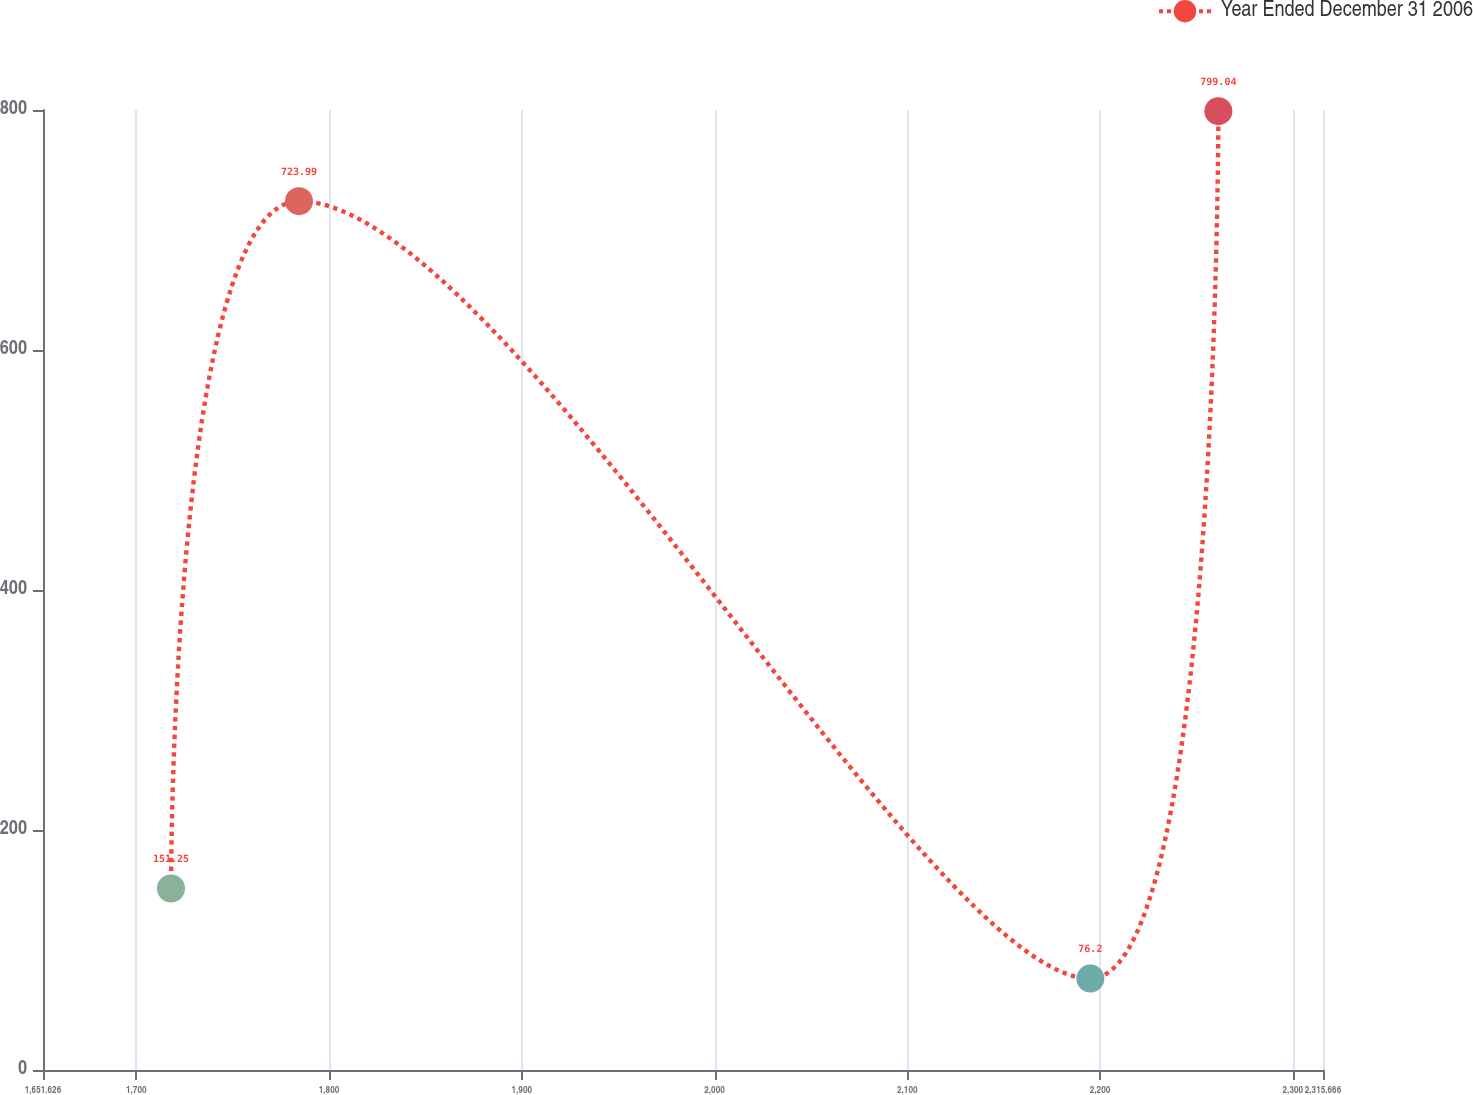<chart> <loc_0><loc_0><loc_500><loc_500><line_chart><ecel><fcel>Year Ended December 31 2006<nl><fcel>1718.03<fcel>151.25<nl><fcel>1784.43<fcel>723.99<nl><fcel>2194.98<fcel>76.2<nl><fcel>2261.38<fcel>799.04<nl><fcel>2382.07<fcel>1.15<nl></chart> 